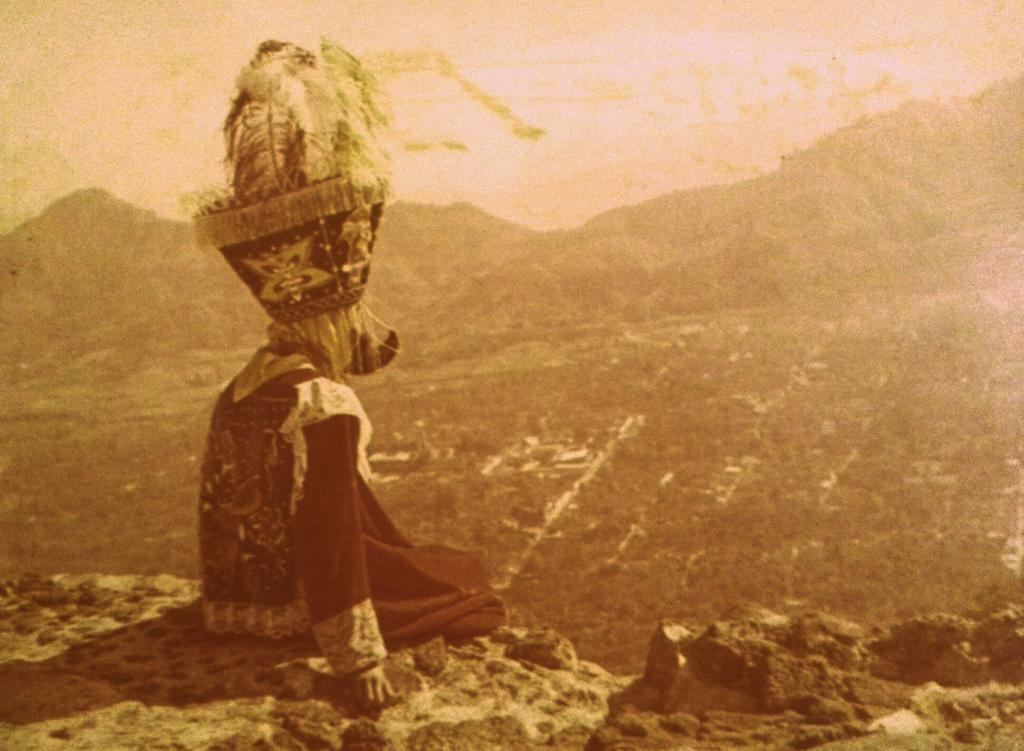What is the person in the image doing? There is a person sitting in the image. What can be seen beneath the person in the image? The ground is visible in the image. What type of natural landscape is visible in the background of the image? There are mountains in the image. What is visible above the person in the image? The sky is visible in the image. What type of ring is the person wearing on their finger in the image? There is no ring visible on the person's finger in the image. What type of birthday celebration is taking place in the image? There is no birthday celebration present in the image. 